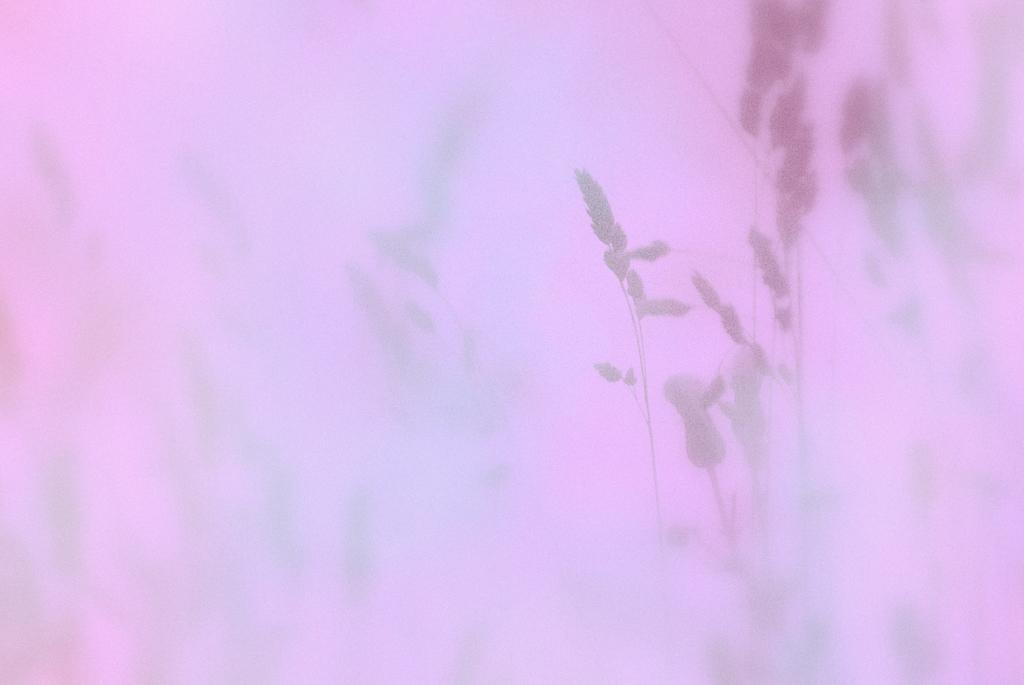What is the overall appearance of the image? The image is blurred. What color dominates the image? The image has a pink color. What type of objects can be seen in the image? There are plants in the image. Where is the hydrant located in the image? There is no hydrant present in the image. What thoughts might the grandmother have while looking at the image? There is no grandmother present in the image, so it is impossible to determine her thoughts. 